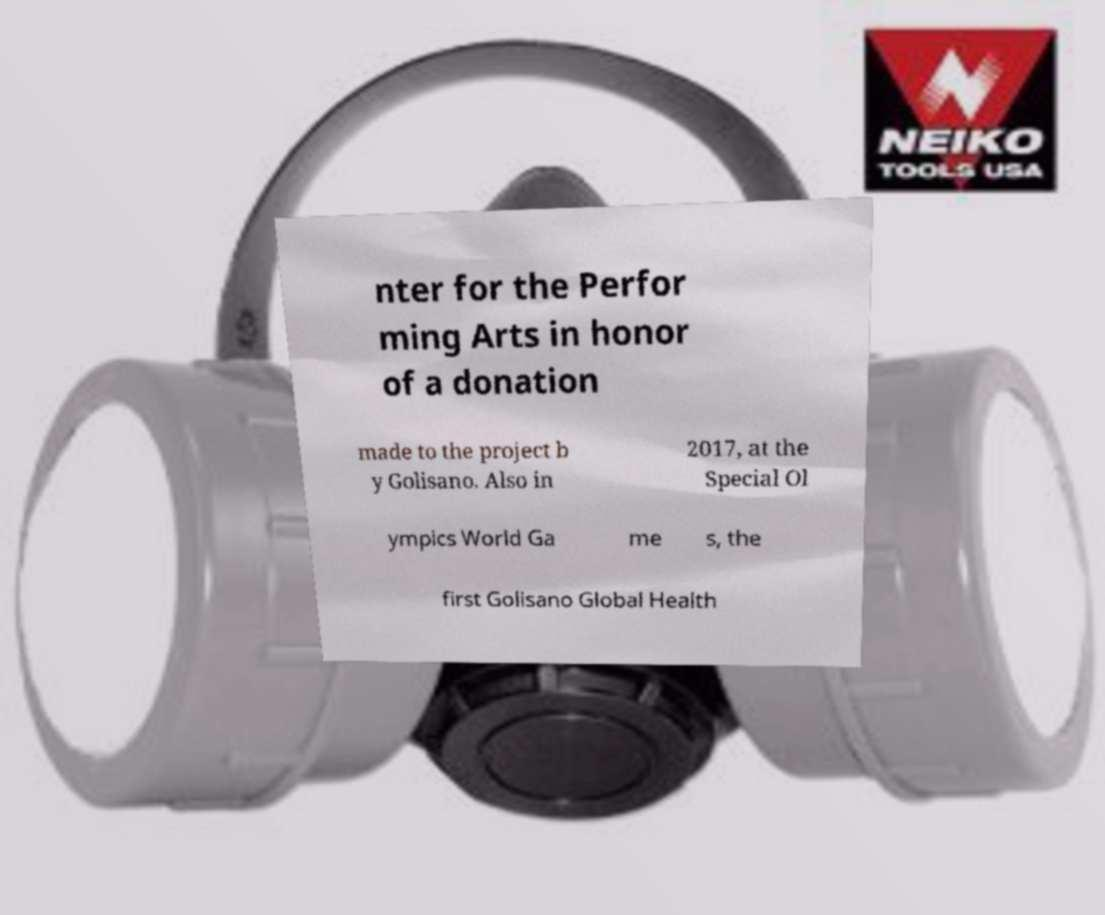Can you accurately transcribe the text from the provided image for me? nter for the Perfor ming Arts in honor of a donation made to the project b y Golisano. Also in 2017, at the Special Ol ympics World Ga me s, the first Golisano Global Health 